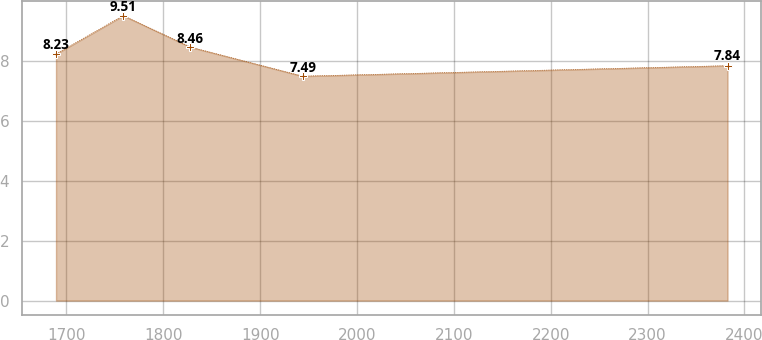Convert chart. <chart><loc_0><loc_0><loc_500><loc_500><line_chart><ecel><fcel>Unnamed: 1<nl><fcel>1689.2<fcel>8.23<nl><fcel>1758.54<fcel>9.51<nl><fcel>1827.88<fcel>8.46<nl><fcel>1943.76<fcel>7.49<nl><fcel>2382.55<fcel>7.84<nl></chart> 